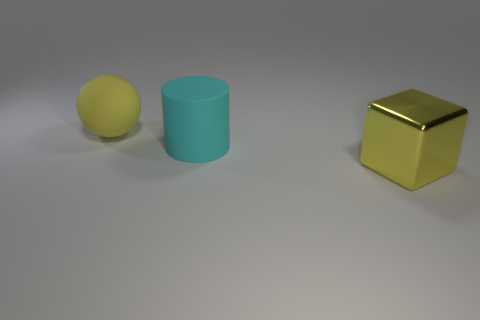Can you describe the lighting and shadows in the scene? The lighting in the scene is subtle and diffused, casting soft shadows that trail to the right of the objects. This suggests a single, broad light source coming from the left, positioned at a moderate height. The softness of the shadows indicates the light has been scattered, likely through some diffusion method to avoid harsh shadows, giving the scene a gentle and even illumination. 